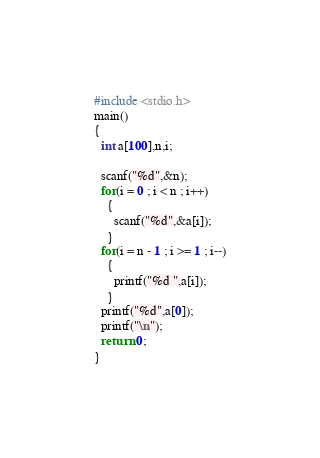Convert code to text. <code><loc_0><loc_0><loc_500><loc_500><_C_>#include <stdio.h>
main()
{
  int a[100],n,i;
  
  scanf("%d",&n);  
  for(i = 0 ; i < n ; i++)
    {
      scanf("%d",&a[i]);
    }
  for(i = n - 1 ; i >= 1 ; i--)
    {
      printf("%d ",a[i]);
    }
  printf("%d",a[0]);
  printf("\n");
  return 0;
}</code> 